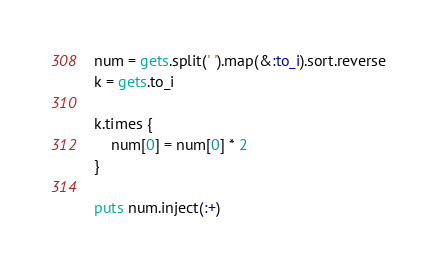<code> <loc_0><loc_0><loc_500><loc_500><_Ruby_>num = gets.split(' ').map(&:to_i).sort.reverse
k = gets.to_i

k.times {
    num[0] = num[0] * 2
}

puts num.inject(:+)</code> 